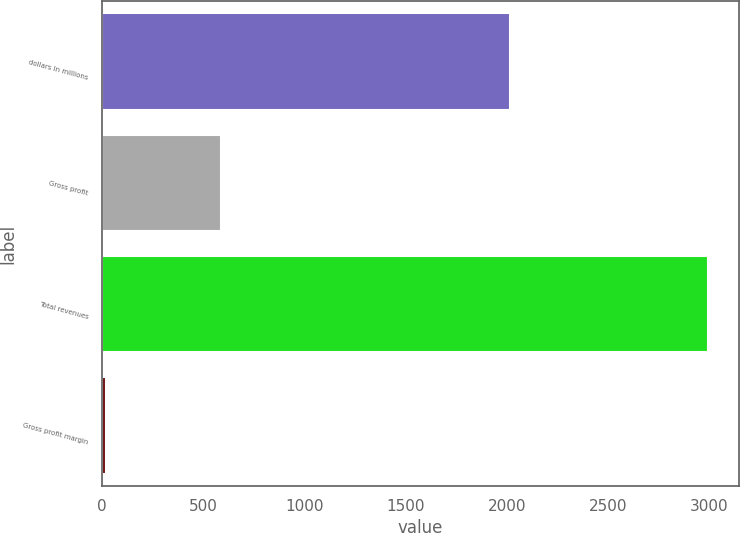Convert chart. <chart><loc_0><loc_0><loc_500><loc_500><bar_chart><fcel>dollars in millions<fcel>Gross profit<fcel>Total revenues<fcel>Gross profit margin<nl><fcel>2014<fcel>587.6<fcel>2994.2<fcel>19.6<nl></chart> 